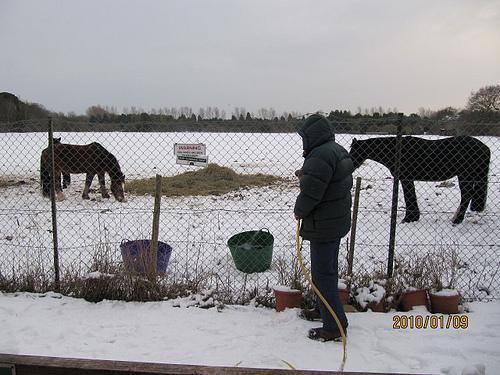What will happen to the water in the hose?
From the following set of four choices, select the accurate answer to respond to the question.
Options: Evaporate, freeze, melt snow, horses drink. Horses drink. 